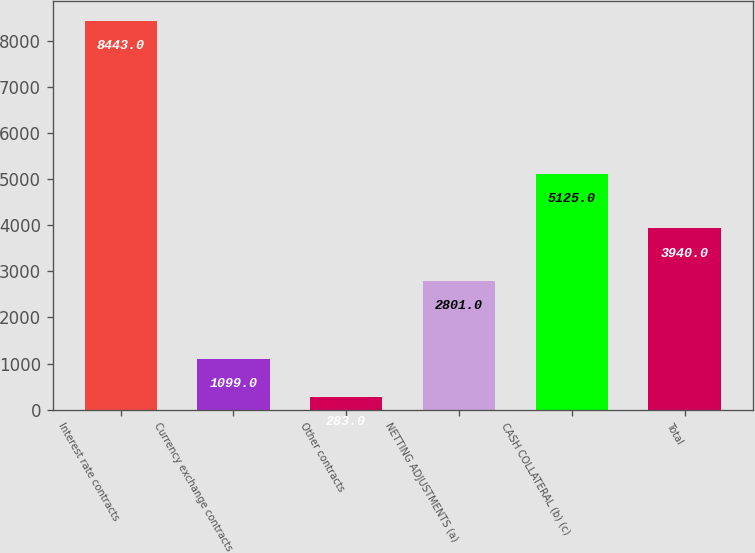Convert chart to OTSL. <chart><loc_0><loc_0><loc_500><loc_500><bar_chart><fcel>Interest rate contracts<fcel>Currency exchange contracts<fcel>Other contracts<fcel>NETTING ADJUSTMENTS (a)<fcel>CASH COLLATERAL (b) (c)<fcel>Total<nl><fcel>8443<fcel>1099<fcel>283<fcel>2801<fcel>5125<fcel>3940<nl></chart> 